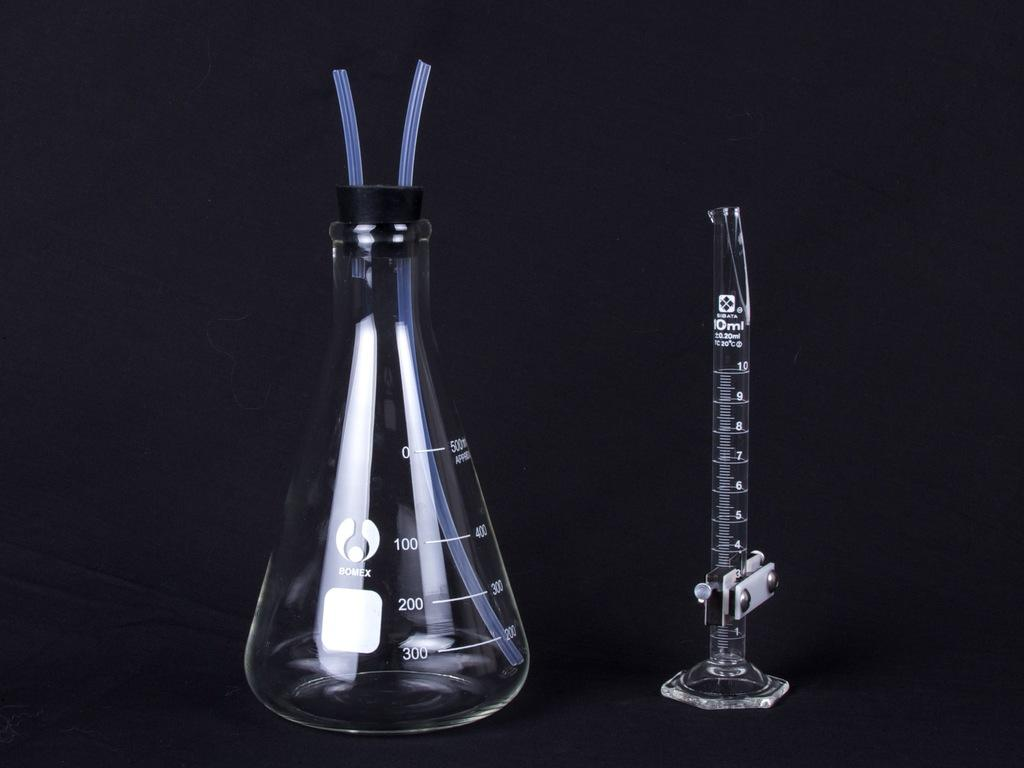<image>
Create a compact narrative representing the image presented. A beaker that measures up to 500 ml and a test tube sit side by side. 